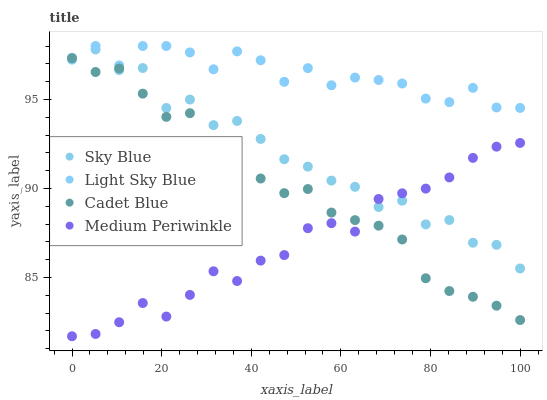Does Medium Periwinkle have the minimum area under the curve?
Answer yes or no. Yes. Does Light Sky Blue have the maximum area under the curve?
Answer yes or no. Yes. Does Sky Blue have the minimum area under the curve?
Answer yes or no. No. Does Sky Blue have the maximum area under the curve?
Answer yes or no. No. Is Cadet Blue the smoothest?
Answer yes or no. Yes. Is Sky Blue the roughest?
Answer yes or no. Yes. Is Light Sky Blue the smoothest?
Answer yes or no. No. Is Light Sky Blue the roughest?
Answer yes or no. No. Does Medium Periwinkle have the lowest value?
Answer yes or no. Yes. Does Sky Blue have the lowest value?
Answer yes or no. No. Does Light Sky Blue have the highest value?
Answer yes or no. Yes. Does Sky Blue have the highest value?
Answer yes or no. No. Is Medium Periwinkle less than Light Sky Blue?
Answer yes or no. Yes. Is Light Sky Blue greater than Medium Periwinkle?
Answer yes or no. Yes. Does Sky Blue intersect Cadet Blue?
Answer yes or no. Yes. Is Sky Blue less than Cadet Blue?
Answer yes or no. No. Is Sky Blue greater than Cadet Blue?
Answer yes or no. No. Does Medium Periwinkle intersect Light Sky Blue?
Answer yes or no. No. 